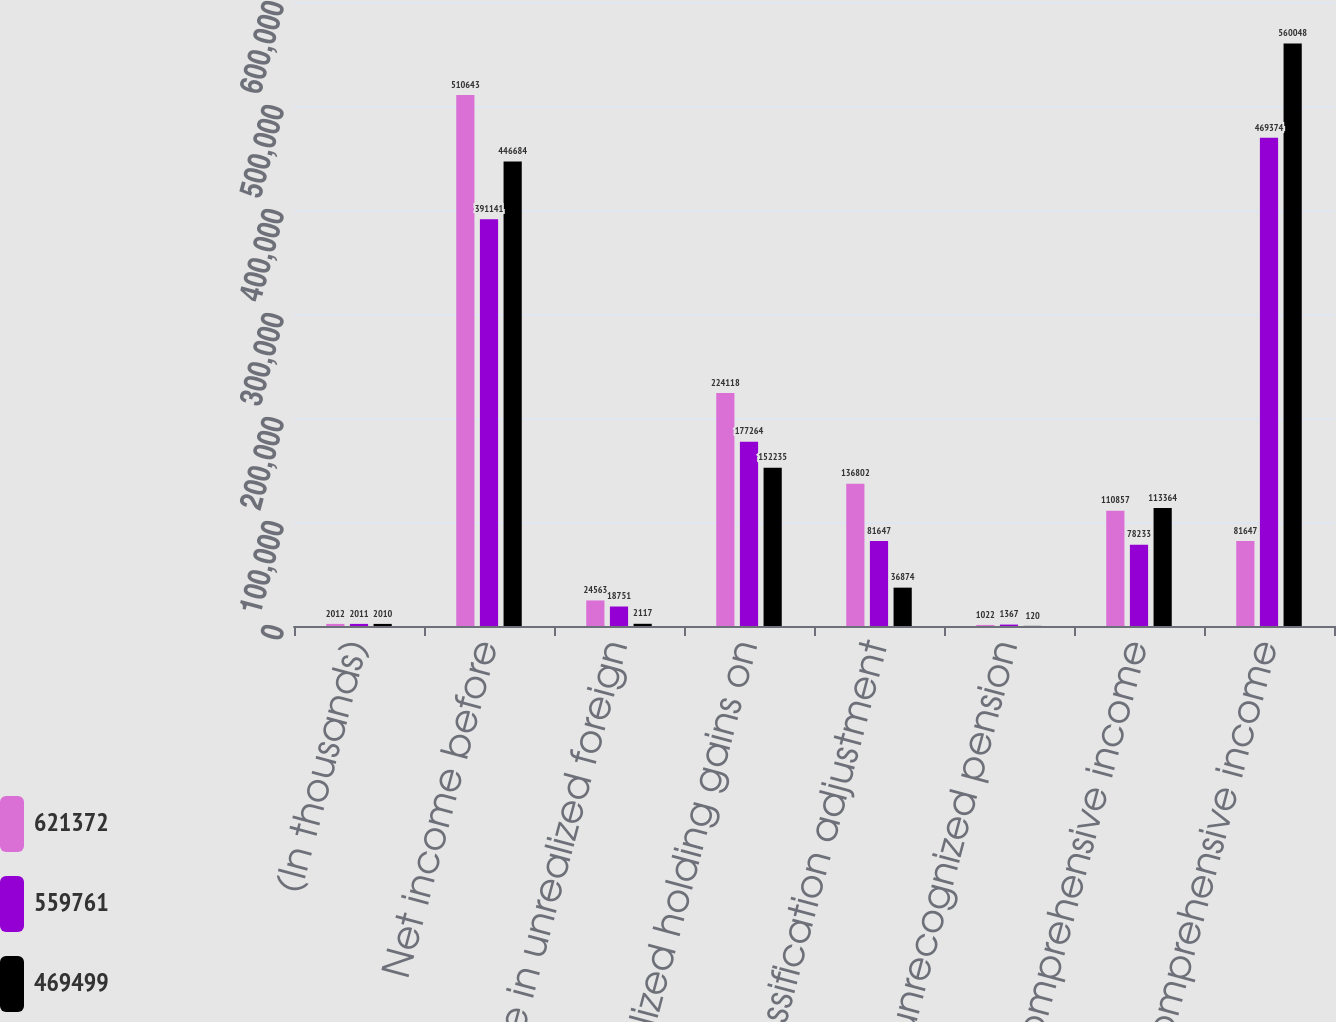Convert chart to OTSL. <chart><loc_0><loc_0><loc_500><loc_500><stacked_bar_chart><ecel><fcel>(In thousands)<fcel>Net income before<fcel>Change in unrealized foreign<fcel>Unrealized holding gains on<fcel>Reclassification adjustment<fcel>Change in unrecognized pension<fcel>Other comprehensive income<fcel>Comprehensive income<nl><fcel>621372<fcel>2012<fcel>510643<fcel>24563<fcel>224118<fcel>136802<fcel>1022<fcel>110857<fcel>81647<nl><fcel>559761<fcel>2011<fcel>391141<fcel>18751<fcel>177264<fcel>81647<fcel>1367<fcel>78233<fcel>469374<nl><fcel>469499<fcel>2010<fcel>446684<fcel>2117<fcel>152235<fcel>36874<fcel>120<fcel>113364<fcel>560048<nl></chart> 